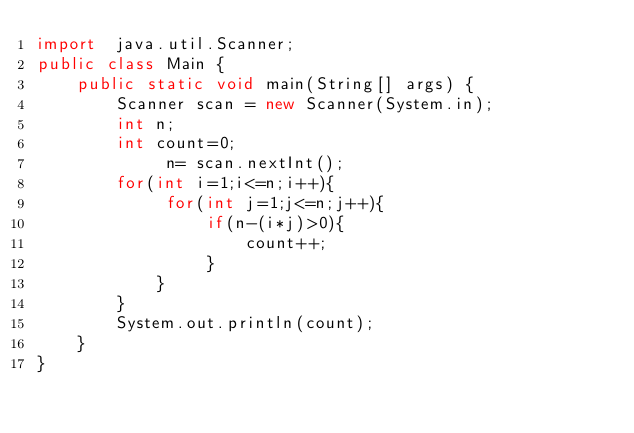Convert code to text. <code><loc_0><loc_0><loc_500><loc_500><_Java_>import  java.util.Scanner;
public class Main {
    public static void main(String[] args) {
        Scanner scan = new Scanner(System.in);
        int n;
        int count=0;
             n= scan.nextInt();
        for(int i=1;i<=n;i++){
             for(int j=1;j<=n;j++){
                 if(n-(i*j)>0){
                     count++;
                 }
            }
        }
        System.out.println(count);
    }
}
</code> 